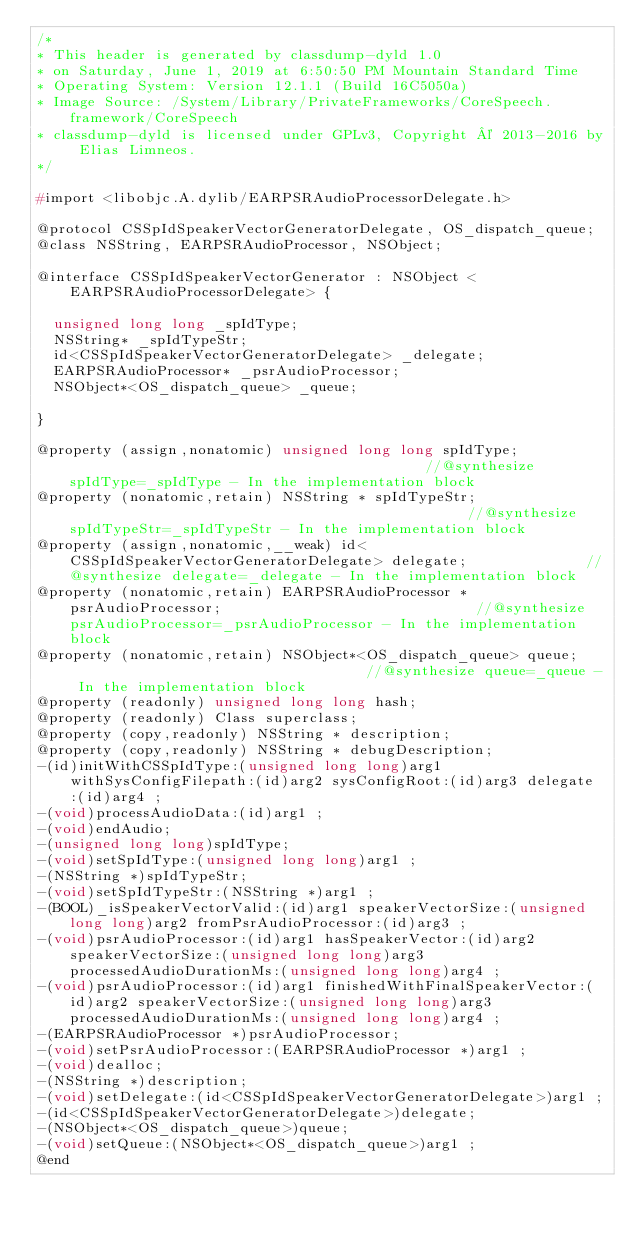Convert code to text. <code><loc_0><loc_0><loc_500><loc_500><_C_>/*
* This header is generated by classdump-dyld 1.0
* on Saturday, June 1, 2019 at 6:50:50 PM Mountain Standard Time
* Operating System: Version 12.1.1 (Build 16C5050a)
* Image Source: /System/Library/PrivateFrameworks/CoreSpeech.framework/CoreSpeech
* classdump-dyld is licensed under GPLv3, Copyright © 2013-2016 by Elias Limneos.
*/

#import <libobjc.A.dylib/EARPSRAudioProcessorDelegate.h>

@protocol CSSpIdSpeakerVectorGeneratorDelegate, OS_dispatch_queue;
@class NSString, EARPSRAudioProcessor, NSObject;

@interface CSSpIdSpeakerVectorGenerator : NSObject <EARPSRAudioProcessorDelegate> {

	unsigned long long _spIdType;
	NSString* _spIdTypeStr;
	id<CSSpIdSpeakerVectorGeneratorDelegate> _delegate;
	EARPSRAudioProcessor* _psrAudioProcessor;
	NSObject*<OS_dispatch_queue> _queue;

}

@property (assign,nonatomic) unsigned long long spIdType;                                           //@synthesize spIdType=_spIdType - In the implementation block
@property (nonatomic,retain) NSString * spIdTypeStr;                                                //@synthesize spIdTypeStr=_spIdTypeStr - In the implementation block
@property (assign,nonatomic,__weak) id<CSSpIdSpeakerVectorGeneratorDelegate> delegate;              //@synthesize delegate=_delegate - In the implementation block
@property (nonatomic,retain) EARPSRAudioProcessor * psrAudioProcessor;                              //@synthesize psrAudioProcessor=_psrAudioProcessor - In the implementation block
@property (nonatomic,retain) NSObject*<OS_dispatch_queue> queue;                                    //@synthesize queue=_queue - In the implementation block
@property (readonly) unsigned long long hash; 
@property (readonly) Class superclass; 
@property (copy,readonly) NSString * description; 
@property (copy,readonly) NSString * debugDescription; 
-(id)initWithCSSpIdType:(unsigned long long)arg1 withSysConfigFilepath:(id)arg2 sysConfigRoot:(id)arg3 delegate:(id)arg4 ;
-(void)processAudioData:(id)arg1 ;
-(void)endAudio;
-(unsigned long long)spIdType;
-(void)setSpIdType:(unsigned long long)arg1 ;
-(NSString *)spIdTypeStr;
-(void)setSpIdTypeStr:(NSString *)arg1 ;
-(BOOL)_isSpeakerVectorValid:(id)arg1 speakerVectorSize:(unsigned long long)arg2 fromPsrAudioProcessor:(id)arg3 ;
-(void)psrAudioProcessor:(id)arg1 hasSpeakerVector:(id)arg2 speakerVectorSize:(unsigned long long)arg3 processedAudioDurationMs:(unsigned long long)arg4 ;
-(void)psrAudioProcessor:(id)arg1 finishedWithFinalSpeakerVector:(id)arg2 speakerVectorSize:(unsigned long long)arg3 processedAudioDurationMs:(unsigned long long)arg4 ;
-(EARPSRAudioProcessor *)psrAudioProcessor;
-(void)setPsrAudioProcessor:(EARPSRAudioProcessor *)arg1 ;
-(void)dealloc;
-(NSString *)description;
-(void)setDelegate:(id<CSSpIdSpeakerVectorGeneratorDelegate>)arg1 ;
-(id<CSSpIdSpeakerVectorGeneratorDelegate>)delegate;
-(NSObject*<OS_dispatch_queue>)queue;
-(void)setQueue:(NSObject*<OS_dispatch_queue>)arg1 ;
@end

</code> 